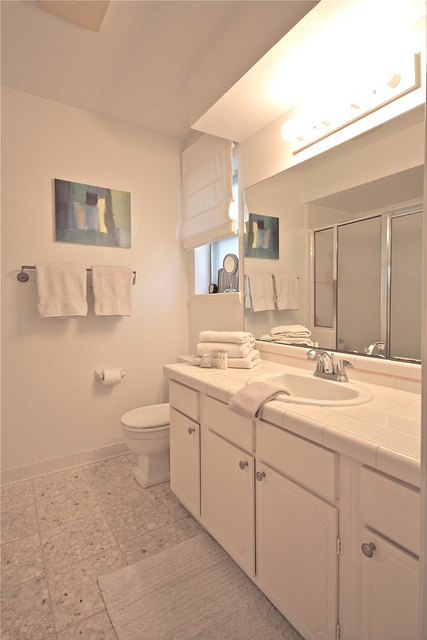How could the lighting in this bathroom be improved to create a more relaxing ambiance? To enhance the relaxing ambiance, warmer toned lighting could replace the current bright lights above the mirror. Installing dimmer switches would offer flexibility in adjusting light intensity to match the mood or time of day. Accent lighting, possibly with recessed LEDs around the mirror or beneath the cabinet, can add a soft glow and can be particularly calming during evening routines. Furthermore, adding one or two scented candles on the countertop can contribute both to the lighting and to a serene atmosphere. 